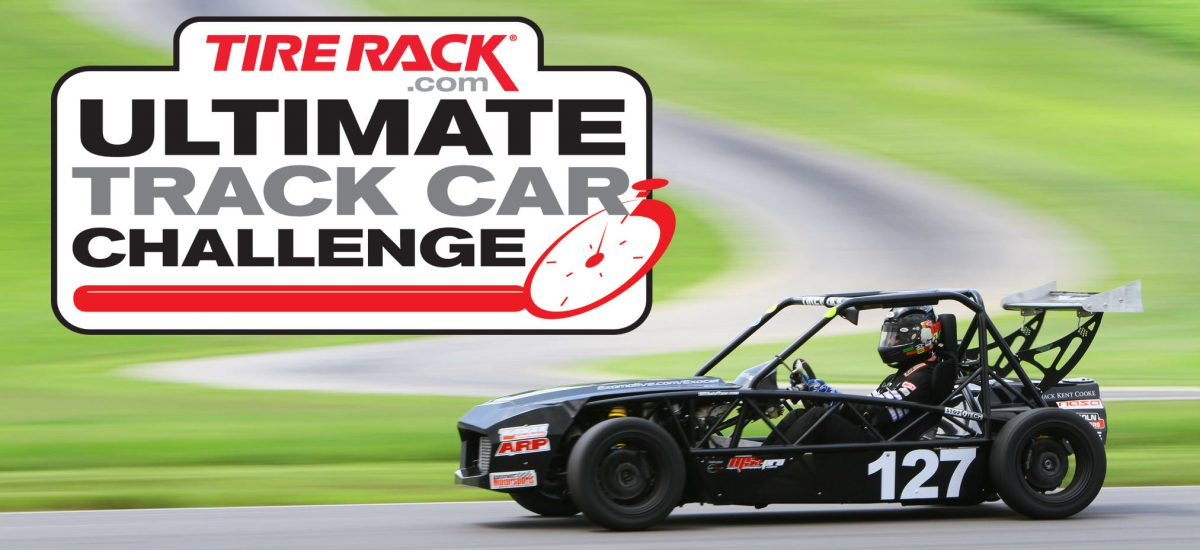Can you tell me what kind of engine might be used in this type of race car and why? Given the car's specialized race build, it's likely to be powered by a high-output, four-cylinder engine, frequently found in this class of track cars due to their excellent power-to-weight ratio. Such an engine is often turbocharged to produce more power and is tuned for a broad torque curve to deliver strong acceleration out of corners, crucial for solo racing events like autocross or time trials. 